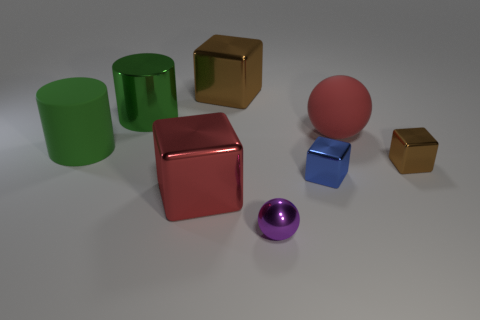Subtract all blue blocks. How many blocks are left? 3 Subtract all large red cubes. How many cubes are left? 3 Subtract all spheres. How many objects are left? 6 Subtract 1 cylinders. How many cylinders are left? 1 Add 1 cyan rubber things. How many objects exist? 9 Subtract all yellow spheres. How many yellow blocks are left? 0 Add 7 metallic balls. How many metallic balls exist? 8 Subtract 0 yellow blocks. How many objects are left? 8 Subtract all brown cylinders. Subtract all blue blocks. How many cylinders are left? 2 Subtract all brown cubes. Subtract all tiny metal balls. How many objects are left? 5 